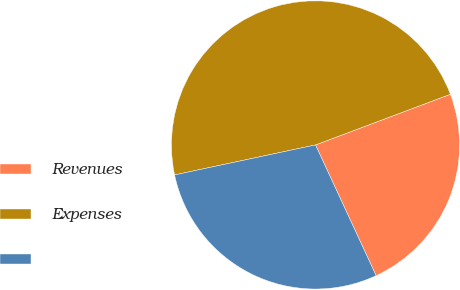Convert chart. <chart><loc_0><loc_0><loc_500><loc_500><pie_chart><fcel>Revenues<fcel>Expenses<fcel>Unnamed: 2<nl><fcel>23.81%<fcel>47.62%<fcel>28.57%<nl></chart> 